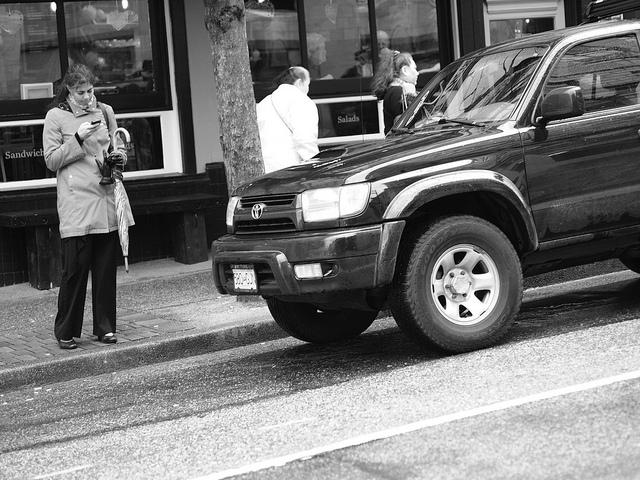Why is the woman looking down into her hand?

Choices:
A) she's frantic
B) she's embarrassed
C) she's crying
D) answering text answering text 